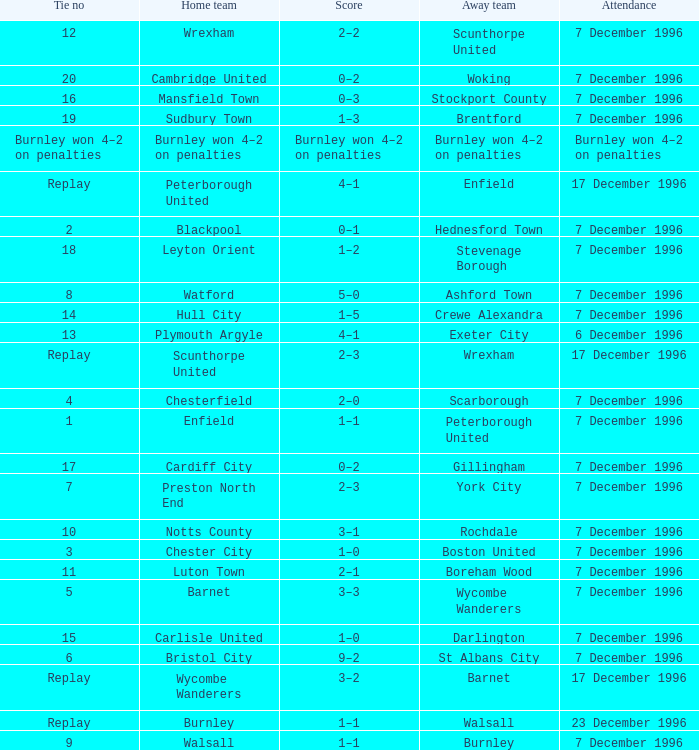What was the score of tie number 15? 1–0. 